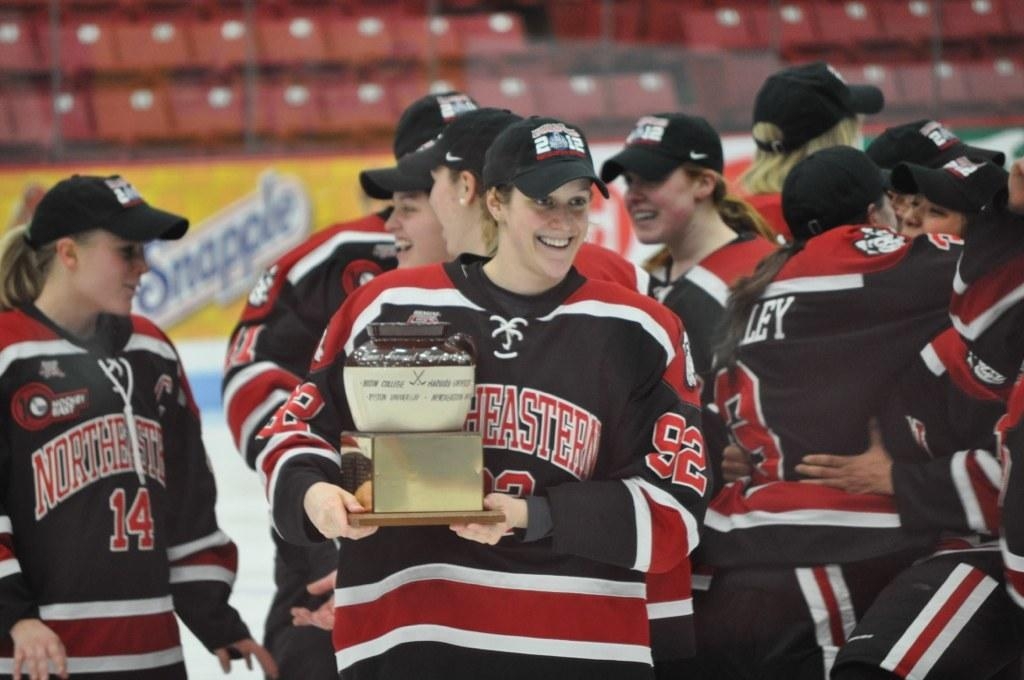Provide a one-sentence caption for the provided image. An ice hockey team with Northeastern on their jerseys celebrate on ice, one member holding an award. 